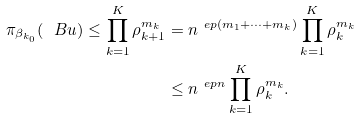<formula> <loc_0><loc_0><loc_500><loc_500>\pi _ { \beta _ { k _ { 0 } } } ( \ B u ) \leq \prod _ { k = 1 } ^ { K } \rho _ { k + 1 } ^ { m _ { k } } & = n ^ { \ e p ( m _ { 1 } + \dots + m _ { k } ) } \prod _ { k = 1 } ^ { K } \rho _ { k } ^ { m _ { k } } \\ & \leq n ^ { \ e p n } \prod _ { k = 1 } ^ { K } \rho _ { k } ^ { m _ { k } } .</formula> 